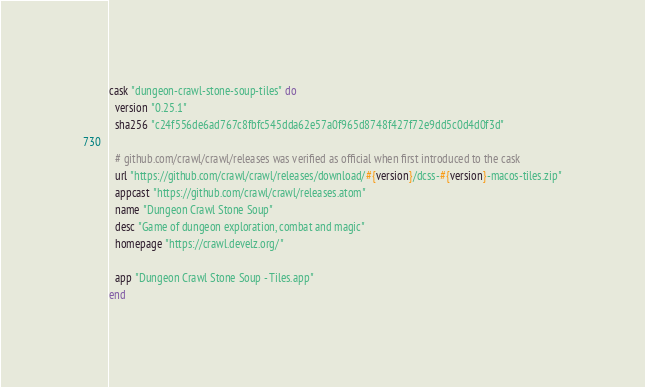<code> <loc_0><loc_0><loc_500><loc_500><_Ruby_>cask "dungeon-crawl-stone-soup-tiles" do
  version "0.25.1"
  sha256 "c24f556de6ad767c8fbfc545dda62e57a0f965d8748f427f72e9dd5c0d4d0f3d"

  # github.com/crawl/crawl/releases was verified as official when first introduced to the cask
  url "https://github.com/crawl/crawl/releases/download/#{version}/dcss-#{version}-macos-tiles.zip"
  appcast "https://github.com/crawl/crawl/releases.atom"
  name "Dungeon Crawl Stone Soup"
  desc "Game of dungeon exploration, combat and magic"
  homepage "https://crawl.develz.org/"

  app "Dungeon Crawl Stone Soup - Tiles.app"
end
</code> 